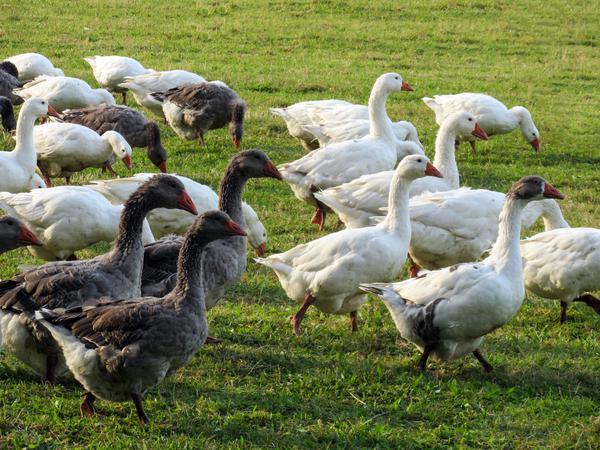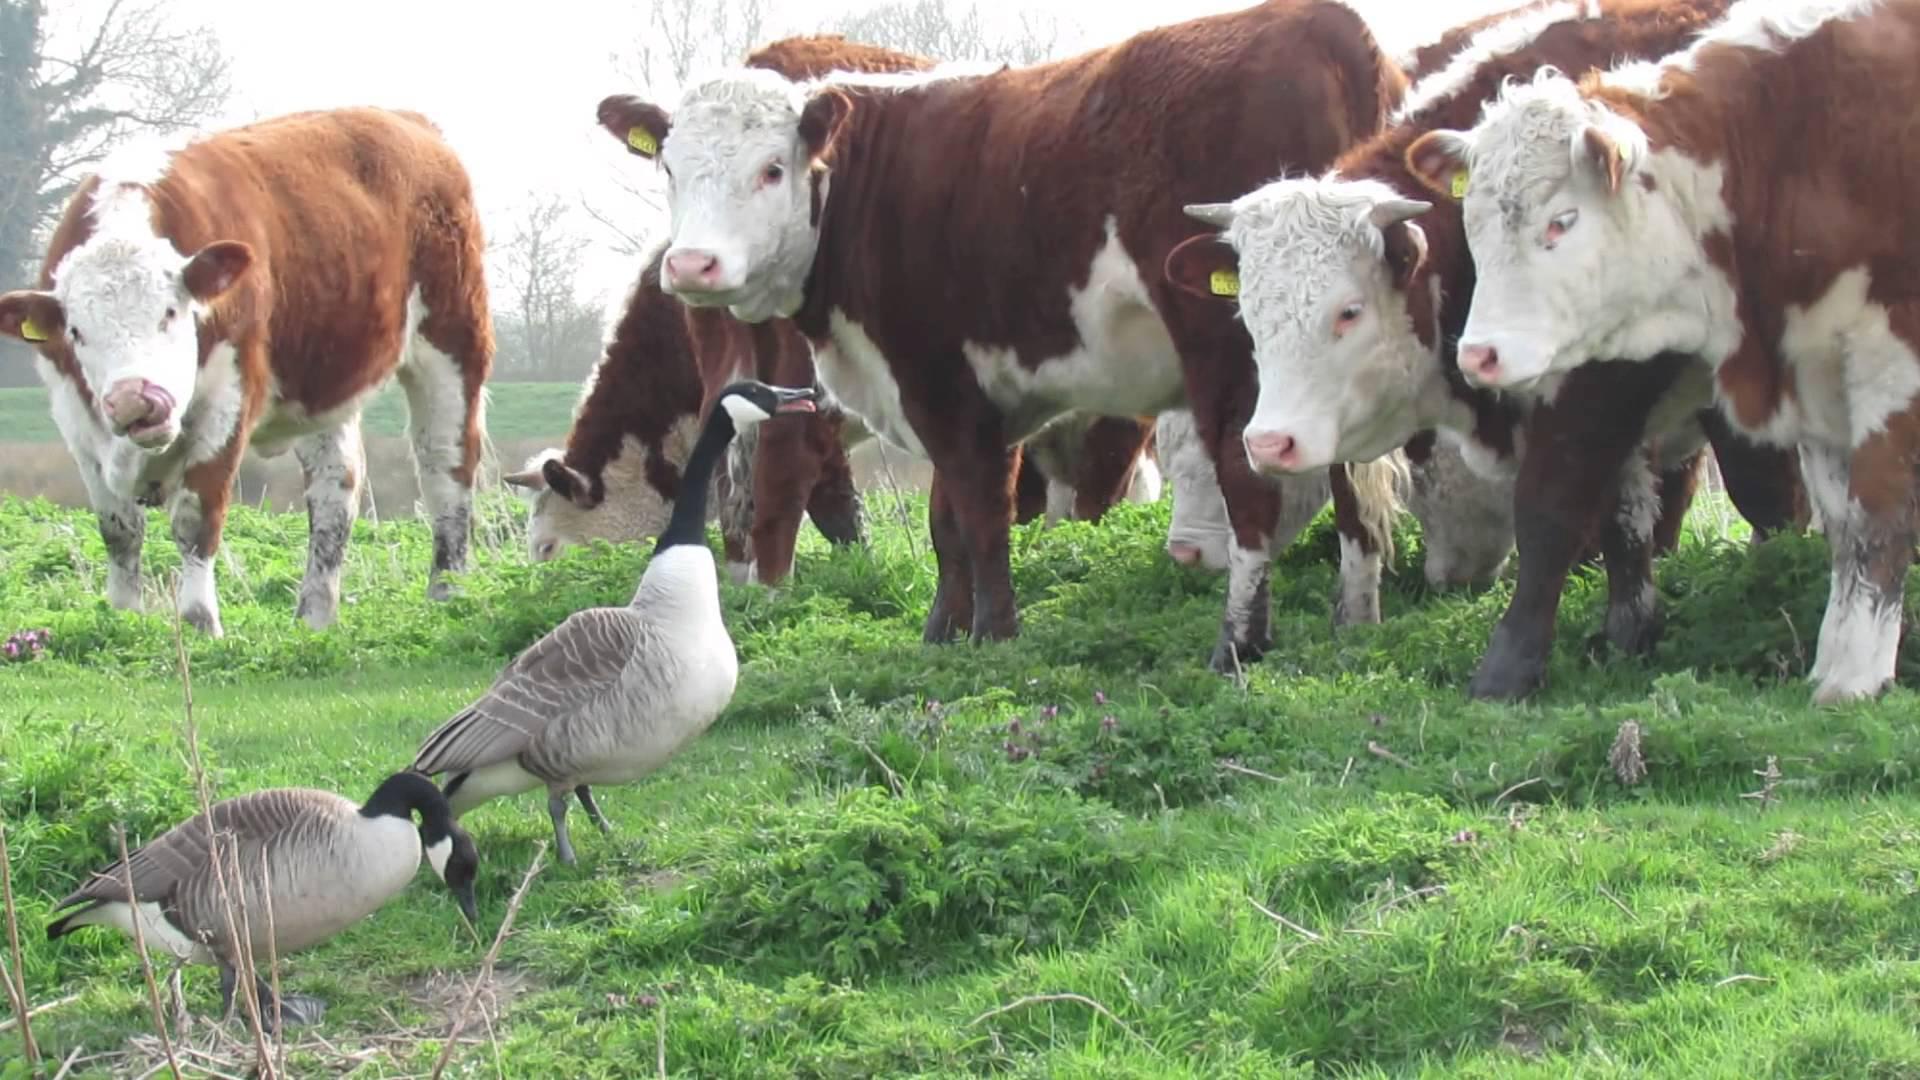The first image is the image on the left, the second image is the image on the right. For the images displayed, is the sentence "One image features multiple ducks on a country road, and the other image shows a mass of white ducks that are not in flight." factually correct? Answer yes or no. No. The first image is the image on the left, the second image is the image on the right. Assess this claim about the two images: "Geese are waddling on a road in both images.". Correct or not? Answer yes or no. No. 